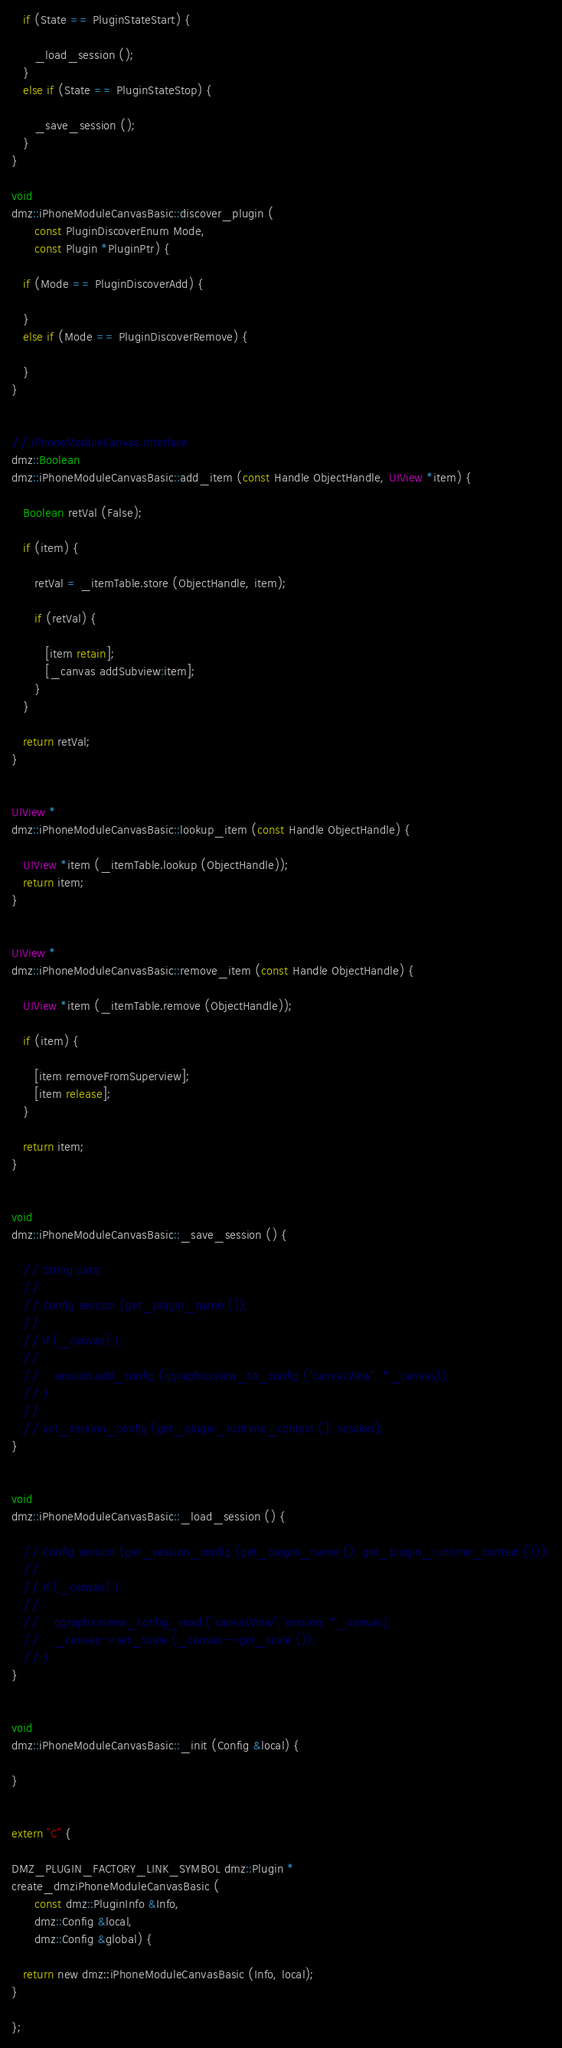Convert code to text. <code><loc_0><loc_0><loc_500><loc_500><_ObjectiveC_>
   if (State == PluginStateStart) {

      _load_session ();
   }
   else if (State == PluginStateStop) {

      _save_session ();
   }
}

void
dmz::iPhoneModuleCanvasBasic::discover_plugin (
      const PluginDiscoverEnum Mode,
      const Plugin *PluginPtr) {

   if (Mode == PluginDiscoverAdd) {

   }
   else if (Mode == PluginDiscoverRemove) {

   }
}


// iPhoneModuleCanvas Interface
dmz::Boolean
dmz::iPhoneModuleCanvasBasic::add_item (const Handle ObjectHandle, UIView *item) {

   Boolean retVal (False);

   if (item) {

      retVal = _itemTable.store (ObjectHandle, item);

      if (retVal) {

         [item retain];
         [_canvas addSubview:item];
      }
   }

   return retVal;
}


UIView *
dmz::iPhoneModuleCanvasBasic::lookup_item (const Handle ObjectHandle) {

   UIView *item (_itemTable.lookup (ObjectHandle));
   return item;
}


UIView *
dmz::iPhoneModuleCanvasBasic::remove_item (const Handle ObjectHandle) {

   UIView *item (_itemTable.remove (ObjectHandle));

   if (item) {

      [item removeFromSuperview];
      [item release];
   }

   return item;
}


void
dmz::iPhoneModuleCanvasBasic::_save_session () {

   // String data;
   //
   // Config session (get_plugin_name ());
   //
   // if (_canvas) {
   //
   //    session.add_config (qgraphicsview_to_config ("canvasView", *_canvas));
   // }
   //
   // set_session_config (get_plugin_runtime_context (), session);
}


void
dmz::iPhoneModuleCanvasBasic::_load_session () {

   // Config session (get_session_config (get_plugin_name (), get_plugin_runtime_context ()));
   //
   // if (_canvas) {
   //
   //    qgraphicsview_config_read ("canvasView", session, *_canvas);
   //    _canvas->set_scale (_canvas->get_scale ());
   // }
}


void
dmz::iPhoneModuleCanvasBasic::_init (Config &local) {

}


extern "C" {

DMZ_PLUGIN_FACTORY_LINK_SYMBOL dmz::Plugin *
create_dmziPhoneModuleCanvasBasic (
      const dmz::PluginInfo &Info,
      dmz::Config &local,
      dmz::Config &global) {

   return new dmz::iPhoneModuleCanvasBasic (Info, local);
}

};
</code> 